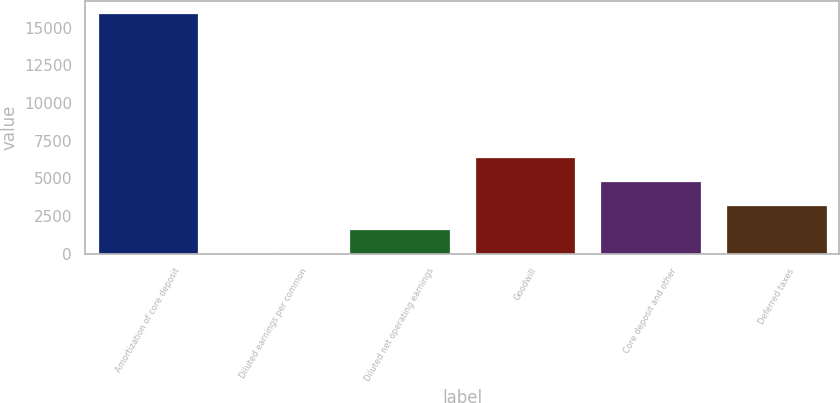Convert chart to OTSL. <chart><loc_0><loc_0><loc_500><loc_500><bar_chart><fcel>Amortization of core deposit<fcel>Diluted earnings per common<fcel>Diluted net operating earnings<fcel>Goodwill<fcel>Core deposit and other<fcel>Deferred taxes<nl><fcel>15971<fcel>0.6<fcel>1597.64<fcel>6388.76<fcel>4791.72<fcel>3194.68<nl></chart> 